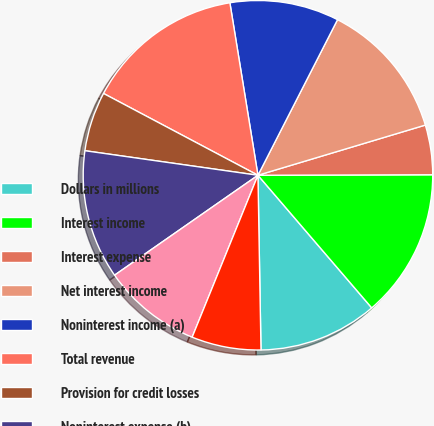Convert chart. <chart><loc_0><loc_0><loc_500><loc_500><pie_chart><fcel>Dollars in millions<fcel>Interest income<fcel>Interest expense<fcel>Net interest income<fcel>Noninterest income (a)<fcel>Total revenue<fcel>Provision for credit losses<fcel>Noninterest expense (b)<fcel>Income before income taxes and<fcel>Income taxes (b)<nl><fcel>11.01%<fcel>13.76%<fcel>4.59%<fcel>12.84%<fcel>10.09%<fcel>14.68%<fcel>5.51%<fcel>11.93%<fcel>9.17%<fcel>6.42%<nl></chart> 